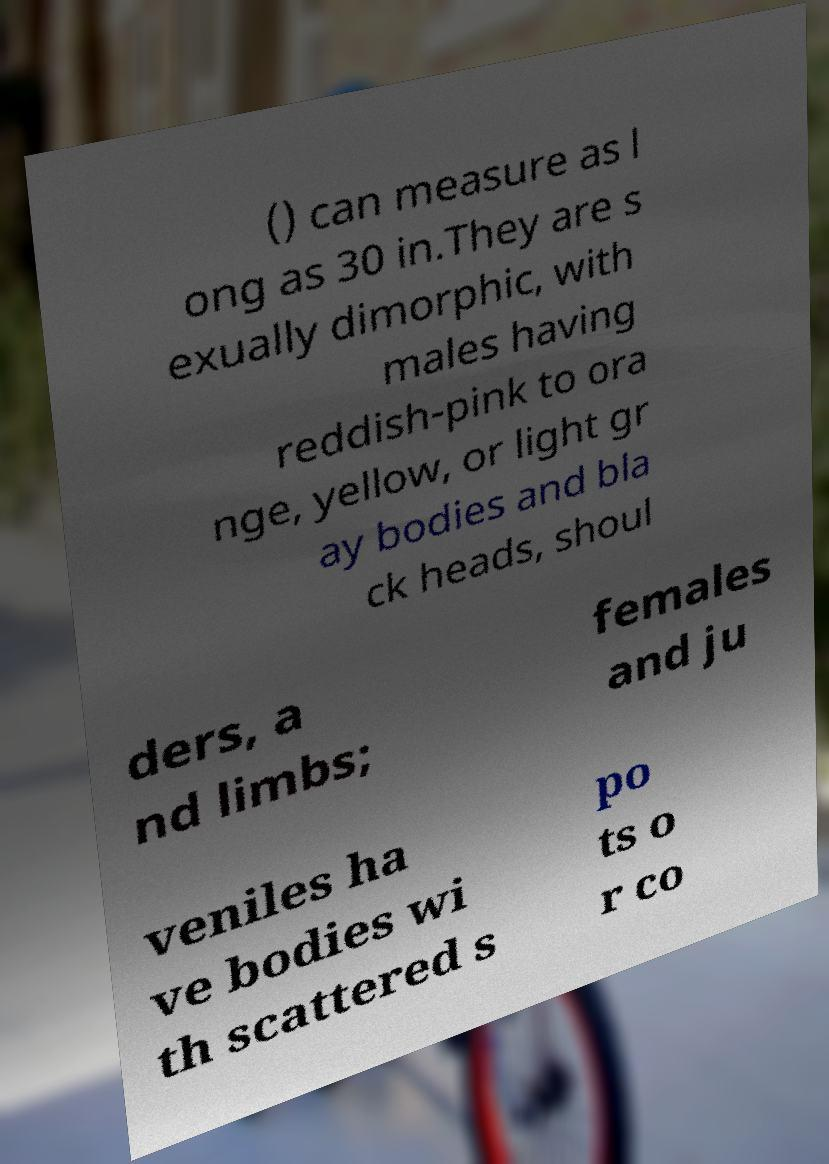Please read and relay the text visible in this image. What does it say? () can measure as l ong as 30 in.They are s exually dimorphic, with males having reddish-pink to ora nge, yellow, or light gr ay bodies and bla ck heads, shoul ders, a nd limbs; females and ju veniles ha ve bodies wi th scattered s po ts o r co 